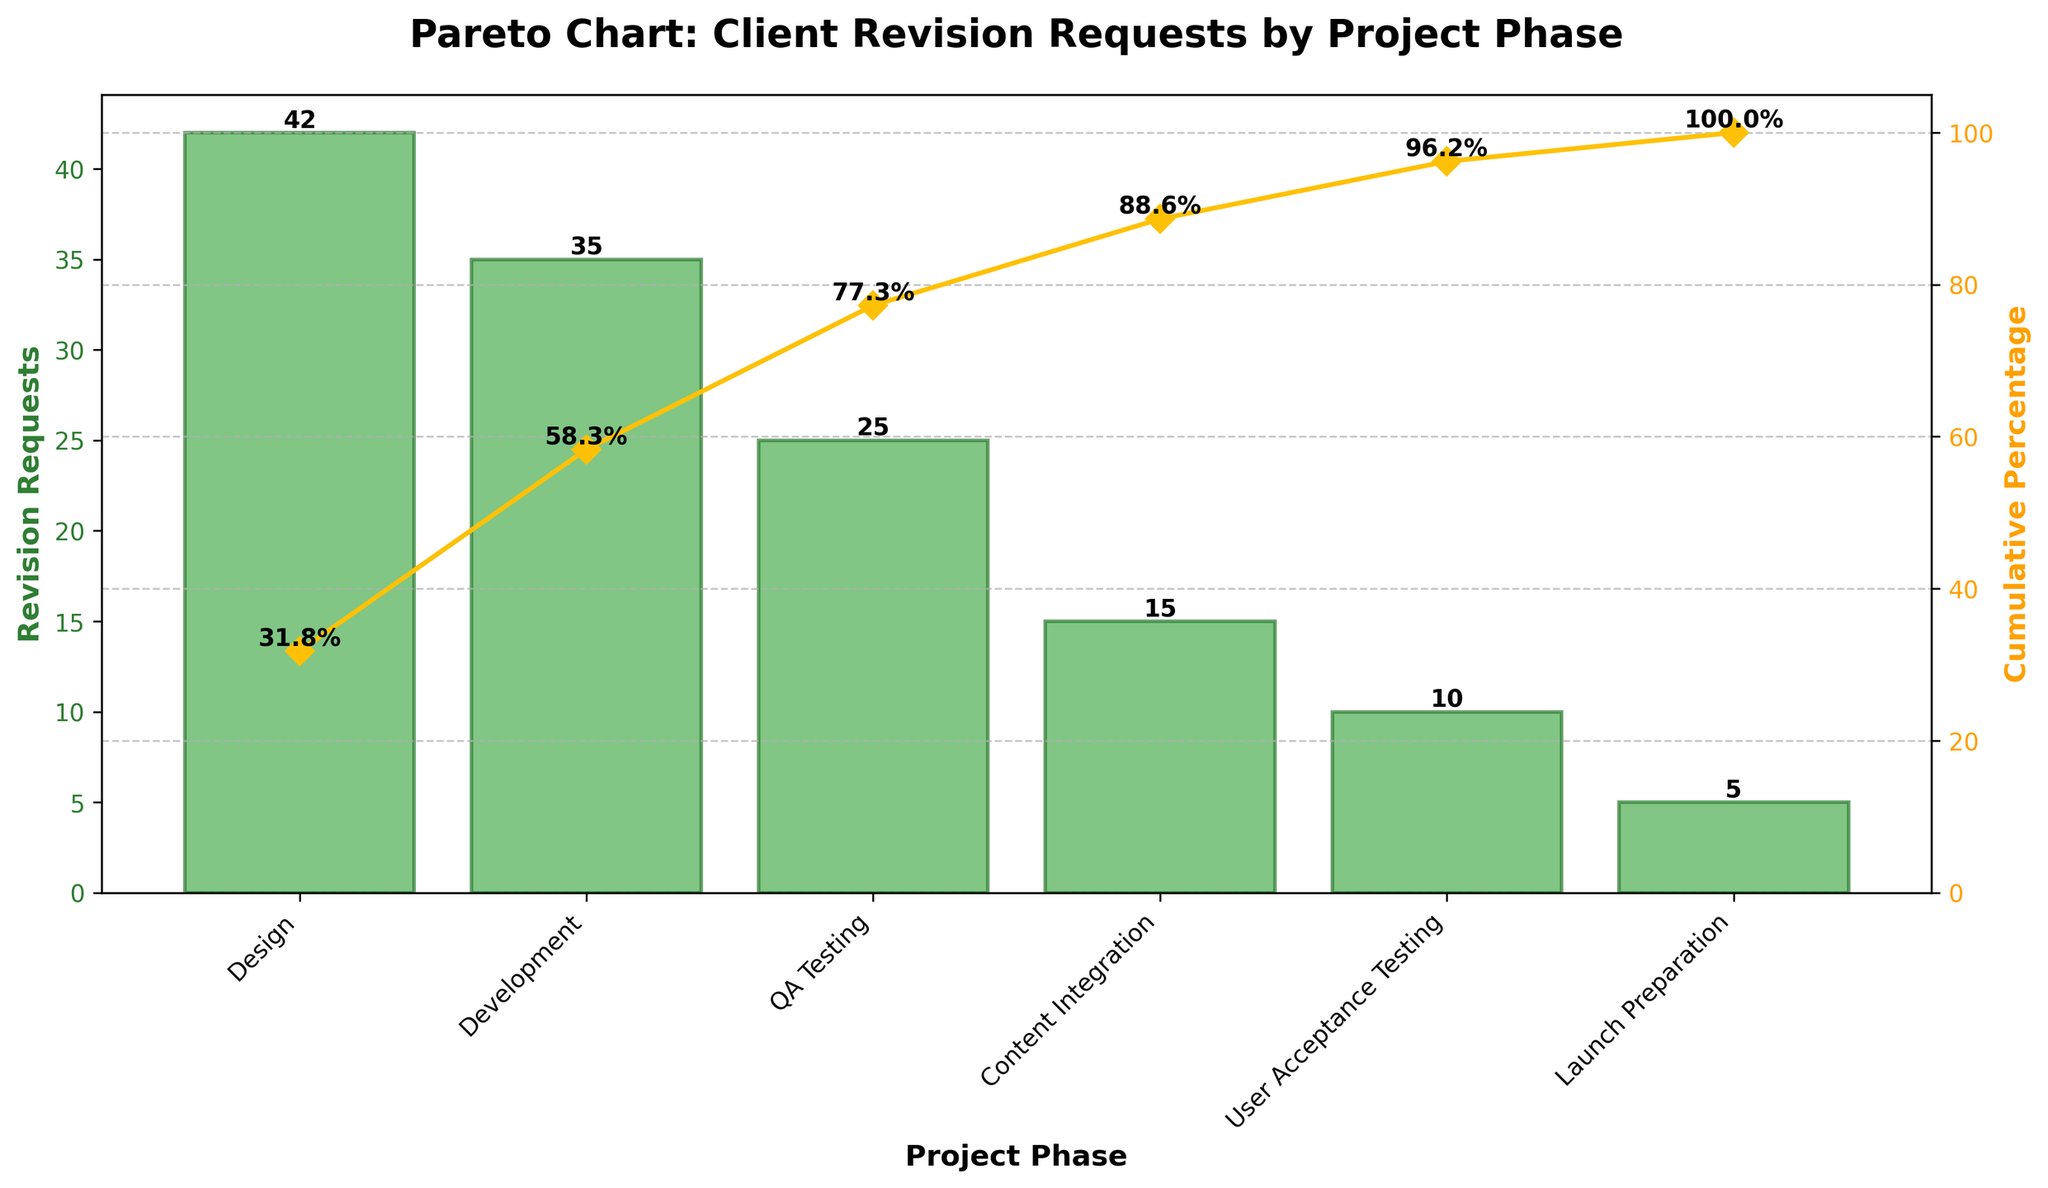What's the total number of revision requests in the "Design" and "Development" phases? The chart shows 42 revision requests in the "Design" phase and 35 revision requests in the "Development" phase. By adding these two numbers, the total is 42 + 35 = 77
Answer: 77 Which project phase has the highest number of revision requests? By looking at the bar heights, the "Design" phase has the highest number with 42 revision requests.
Answer: Design What is the cumulative percentage of revision requests by the "QA Testing" phase? The chart indicates the cumulative percentage values on the secondary y-axis. For "QA Testing", it is 77.27%.
Answer: 77.27% How many revision requests are there in the three highest requesting phases combined? The top three phases by revision requests are "Design" (42), "Development" (35), and "QA Testing" (25). Summing these gives 42 + 35 + 25 = 102.
Answer: 102 What is the difference in cumulative percentage between the "User Acceptance Testing" and "Launch Preparation" phases? The cumulative percentage for "User Acceptance Testing" is 96.21%, and for "Launch Preparation" it is 100.00%. The difference is 100.00% - 96.21% = 3.79%.
Answer: 3.79% What percentage of revision requests occur before the "Content Integration" phase? From the cumulative percentage values, "Content Integration" starts at 77.27%. Thus, the percentage before it is 77.27%.
Answer: 77.27% Which two phases have the smallest difference in the number of revision requests? Comparing the values, "Launch Preparation" has 5 requests and "User Acceptance Testing" has 10 requests. The difference is 10 - 5 = 5, which is the smallest difference.
Answer: Launch Preparation and User Acceptance Testing What is the average number of revision requests across all phases? Add all requests: 42 (Design) + 35 (Development) + 25 (QA Testing) + 15 (Content Integration) + 10 (User Acceptance Testing) + 5 (Launch Preparation) = 132. Then, divide by the number of phases, which is 6. So, 132 / 6 = 22.
Answer: 22 How does the number of revision requests in the "Content Integration" phase compare to the "Design" and "Development" phases? Content Integration has 15 requests, while Design has 42 and Development has 35. Both Design and Development have more requests than Content Integration.
Answer: Both Design and Development have more requests What phase marks the 75th percentile in cumulative percentage? The 75th percentile is approximately three-quarters of the total range. Phases reaching close to this are QA Testing at 77.27%.
Answer: QA Testing 